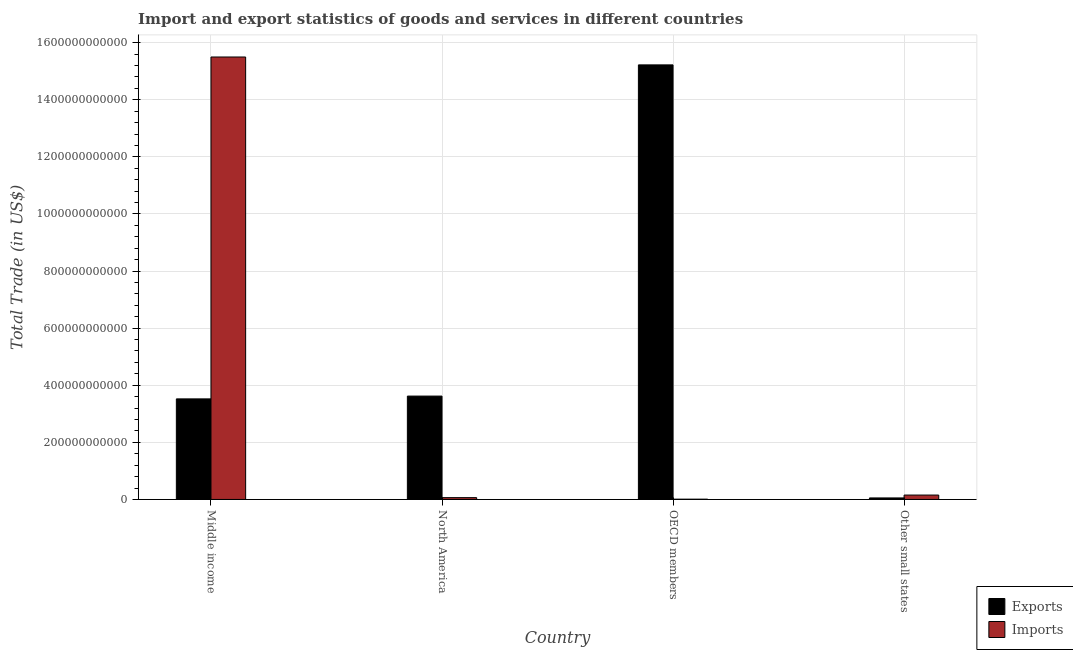Are the number of bars on each tick of the X-axis equal?
Offer a very short reply. Yes. How many bars are there on the 1st tick from the right?
Ensure brevity in your answer.  2. What is the label of the 4th group of bars from the left?
Make the answer very short. Other small states. In how many cases, is the number of bars for a given country not equal to the number of legend labels?
Give a very brief answer. 0. What is the export of goods and services in Middle income?
Give a very brief answer. 3.52e+11. Across all countries, what is the maximum export of goods and services?
Ensure brevity in your answer.  1.52e+12. Across all countries, what is the minimum imports of goods and services?
Give a very brief answer. 9.81e+08. In which country was the imports of goods and services maximum?
Your response must be concise. Middle income. In which country was the export of goods and services minimum?
Your answer should be compact. Other small states. What is the total imports of goods and services in the graph?
Your response must be concise. 1.57e+12. What is the difference between the imports of goods and services in North America and that in OECD members?
Offer a very short reply. 5.40e+09. What is the difference between the imports of goods and services in OECD members and the export of goods and services in Other small states?
Provide a succinct answer. -4.36e+09. What is the average imports of goods and services per country?
Make the answer very short. 3.93e+11. What is the difference between the export of goods and services and imports of goods and services in North America?
Your response must be concise. 3.56e+11. What is the ratio of the export of goods and services in Middle income to that in OECD members?
Offer a terse response. 0.23. Is the imports of goods and services in Middle income less than that in North America?
Offer a terse response. No. What is the difference between the highest and the second highest export of goods and services?
Your answer should be compact. 1.16e+12. What is the difference between the highest and the lowest export of goods and services?
Provide a succinct answer. 1.52e+12. What does the 1st bar from the left in Middle income represents?
Offer a very short reply. Exports. What does the 1st bar from the right in North America represents?
Offer a very short reply. Imports. What is the difference between two consecutive major ticks on the Y-axis?
Offer a very short reply. 2.00e+11. Where does the legend appear in the graph?
Provide a succinct answer. Bottom right. How many legend labels are there?
Your response must be concise. 2. How are the legend labels stacked?
Give a very brief answer. Vertical. What is the title of the graph?
Your response must be concise. Import and export statistics of goods and services in different countries. Does "Females" appear as one of the legend labels in the graph?
Provide a short and direct response. No. What is the label or title of the Y-axis?
Your answer should be compact. Total Trade (in US$). What is the Total Trade (in US$) of Exports in Middle income?
Ensure brevity in your answer.  3.52e+11. What is the Total Trade (in US$) of Imports in Middle income?
Offer a very short reply. 1.55e+12. What is the Total Trade (in US$) of Exports in North America?
Ensure brevity in your answer.  3.62e+11. What is the Total Trade (in US$) of Imports in North America?
Your answer should be very brief. 6.38e+09. What is the Total Trade (in US$) in Exports in OECD members?
Your answer should be compact. 1.52e+12. What is the Total Trade (in US$) of Imports in OECD members?
Provide a succinct answer. 9.81e+08. What is the Total Trade (in US$) in Exports in Other small states?
Give a very brief answer. 5.34e+09. What is the Total Trade (in US$) in Imports in Other small states?
Offer a terse response. 1.54e+1. Across all countries, what is the maximum Total Trade (in US$) of Exports?
Ensure brevity in your answer.  1.52e+12. Across all countries, what is the maximum Total Trade (in US$) in Imports?
Keep it short and to the point. 1.55e+12. Across all countries, what is the minimum Total Trade (in US$) of Exports?
Make the answer very short. 5.34e+09. Across all countries, what is the minimum Total Trade (in US$) in Imports?
Keep it short and to the point. 9.81e+08. What is the total Total Trade (in US$) in Exports in the graph?
Ensure brevity in your answer.  2.24e+12. What is the total Total Trade (in US$) in Imports in the graph?
Offer a terse response. 1.57e+12. What is the difference between the Total Trade (in US$) of Exports in Middle income and that in North America?
Provide a short and direct response. -9.78e+09. What is the difference between the Total Trade (in US$) in Imports in Middle income and that in North America?
Offer a terse response. 1.54e+12. What is the difference between the Total Trade (in US$) in Exports in Middle income and that in OECD members?
Keep it short and to the point. -1.17e+12. What is the difference between the Total Trade (in US$) in Imports in Middle income and that in OECD members?
Make the answer very short. 1.55e+12. What is the difference between the Total Trade (in US$) in Exports in Middle income and that in Other small states?
Offer a terse response. 3.47e+11. What is the difference between the Total Trade (in US$) of Imports in Middle income and that in Other small states?
Provide a short and direct response. 1.53e+12. What is the difference between the Total Trade (in US$) in Exports in North America and that in OECD members?
Keep it short and to the point. -1.16e+12. What is the difference between the Total Trade (in US$) of Imports in North America and that in OECD members?
Provide a short and direct response. 5.40e+09. What is the difference between the Total Trade (in US$) in Exports in North America and that in Other small states?
Ensure brevity in your answer.  3.57e+11. What is the difference between the Total Trade (in US$) of Imports in North America and that in Other small states?
Give a very brief answer. -9.04e+09. What is the difference between the Total Trade (in US$) in Exports in OECD members and that in Other small states?
Your response must be concise. 1.52e+12. What is the difference between the Total Trade (in US$) of Imports in OECD members and that in Other small states?
Your answer should be very brief. -1.44e+1. What is the difference between the Total Trade (in US$) in Exports in Middle income and the Total Trade (in US$) in Imports in North America?
Offer a terse response. 3.46e+11. What is the difference between the Total Trade (in US$) of Exports in Middle income and the Total Trade (in US$) of Imports in OECD members?
Your answer should be very brief. 3.51e+11. What is the difference between the Total Trade (in US$) in Exports in Middle income and the Total Trade (in US$) in Imports in Other small states?
Make the answer very short. 3.37e+11. What is the difference between the Total Trade (in US$) in Exports in North America and the Total Trade (in US$) in Imports in OECD members?
Ensure brevity in your answer.  3.61e+11. What is the difference between the Total Trade (in US$) in Exports in North America and the Total Trade (in US$) in Imports in Other small states?
Keep it short and to the point. 3.47e+11. What is the difference between the Total Trade (in US$) of Exports in OECD members and the Total Trade (in US$) of Imports in Other small states?
Make the answer very short. 1.51e+12. What is the average Total Trade (in US$) of Exports per country?
Make the answer very short. 5.60e+11. What is the average Total Trade (in US$) of Imports per country?
Keep it short and to the point. 3.93e+11. What is the difference between the Total Trade (in US$) of Exports and Total Trade (in US$) of Imports in Middle income?
Make the answer very short. -1.20e+12. What is the difference between the Total Trade (in US$) of Exports and Total Trade (in US$) of Imports in North America?
Give a very brief answer. 3.56e+11. What is the difference between the Total Trade (in US$) of Exports and Total Trade (in US$) of Imports in OECD members?
Give a very brief answer. 1.52e+12. What is the difference between the Total Trade (in US$) of Exports and Total Trade (in US$) of Imports in Other small states?
Ensure brevity in your answer.  -1.01e+1. What is the ratio of the Total Trade (in US$) of Imports in Middle income to that in North America?
Your response must be concise. 243.03. What is the ratio of the Total Trade (in US$) in Exports in Middle income to that in OECD members?
Your answer should be very brief. 0.23. What is the ratio of the Total Trade (in US$) of Imports in Middle income to that in OECD members?
Provide a succinct answer. 1580.14. What is the ratio of the Total Trade (in US$) of Exports in Middle income to that in Other small states?
Make the answer very short. 65.96. What is the ratio of the Total Trade (in US$) in Imports in Middle income to that in Other small states?
Your answer should be very brief. 100.51. What is the ratio of the Total Trade (in US$) of Exports in North America to that in OECD members?
Your answer should be compact. 0.24. What is the ratio of the Total Trade (in US$) of Imports in North America to that in OECD members?
Make the answer very short. 6.5. What is the ratio of the Total Trade (in US$) in Exports in North America to that in Other small states?
Ensure brevity in your answer.  67.79. What is the ratio of the Total Trade (in US$) of Imports in North America to that in Other small states?
Ensure brevity in your answer.  0.41. What is the ratio of the Total Trade (in US$) in Exports in OECD members to that in Other small states?
Offer a very short reply. 285.01. What is the ratio of the Total Trade (in US$) in Imports in OECD members to that in Other small states?
Provide a short and direct response. 0.06. What is the difference between the highest and the second highest Total Trade (in US$) of Exports?
Your answer should be very brief. 1.16e+12. What is the difference between the highest and the second highest Total Trade (in US$) of Imports?
Keep it short and to the point. 1.53e+12. What is the difference between the highest and the lowest Total Trade (in US$) of Exports?
Your response must be concise. 1.52e+12. What is the difference between the highest and the lowest Total Trade (in US$) in Imports?
Provide a succinct answer. 1.55e+12. 